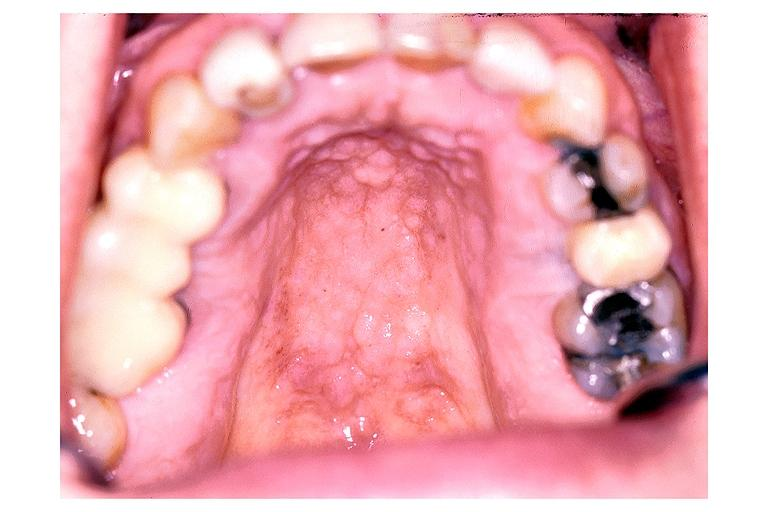s oral present?
Answer the question using a single word or phrase. Yes 